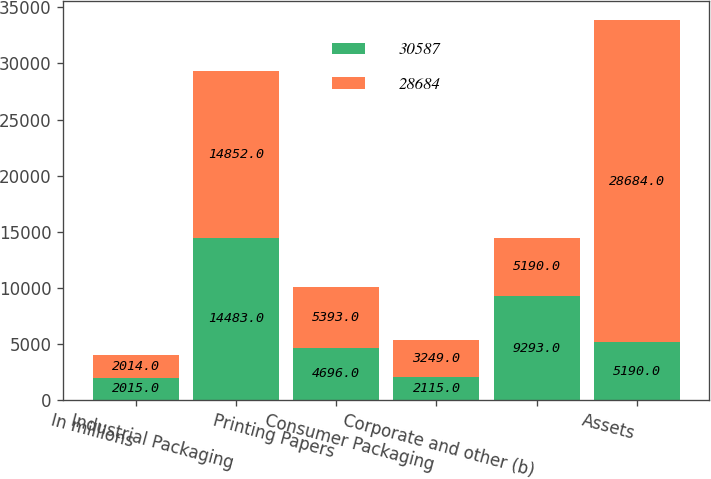Convert chart to OTSL. <chart><loc_0><loc_0><loc_500><loc_500><stacked_bar_chart><ecel><fcel>In millions<fcel>Industrial Packaging<fcel>Printing Papers<fcel>Consumer Packaging<fcel>Corporate and other (b)<fcel>Assets<nl><fcel>30587<fcel>2015<fcel>14483<fcel>4696<fcel>2115<fcel>9293<fcel>5190<nl><fcel>28684<fcel>2014<fcel>14852<fcel>5393<fcel>3249<fcel>5190<fcel>28684<nl></chart> 